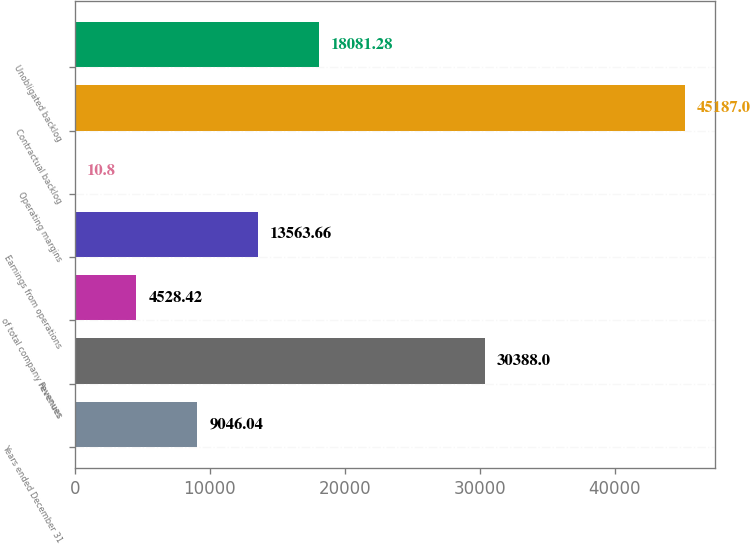Convert chart to OTSL. <chart><loc_0><loc_0><loc_500><loc_500><bar_chart><fcel>Years ended December 31<fcel>Revenues<fcel>of total company revenues<fcel>Earnings from operations<fcel>Operating margins<fcel>Contractual backlog<fcel>Unobligated backlog<nl><fcel>9046.04<fcel>30388<fcel>4528.42<fcel>13563.7<fcel>10.8<fcel>45187<fcel>18081.3<nl></chart> 